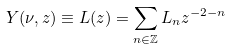<formula> <loc_0><loc_0><loc_500><loc_500>Y ( \nu , z ) \equiv L ( z ) = \sum _ { n \in \mathbb { Z } } L _ { n } z ^ { - 2 - n }</formula> 